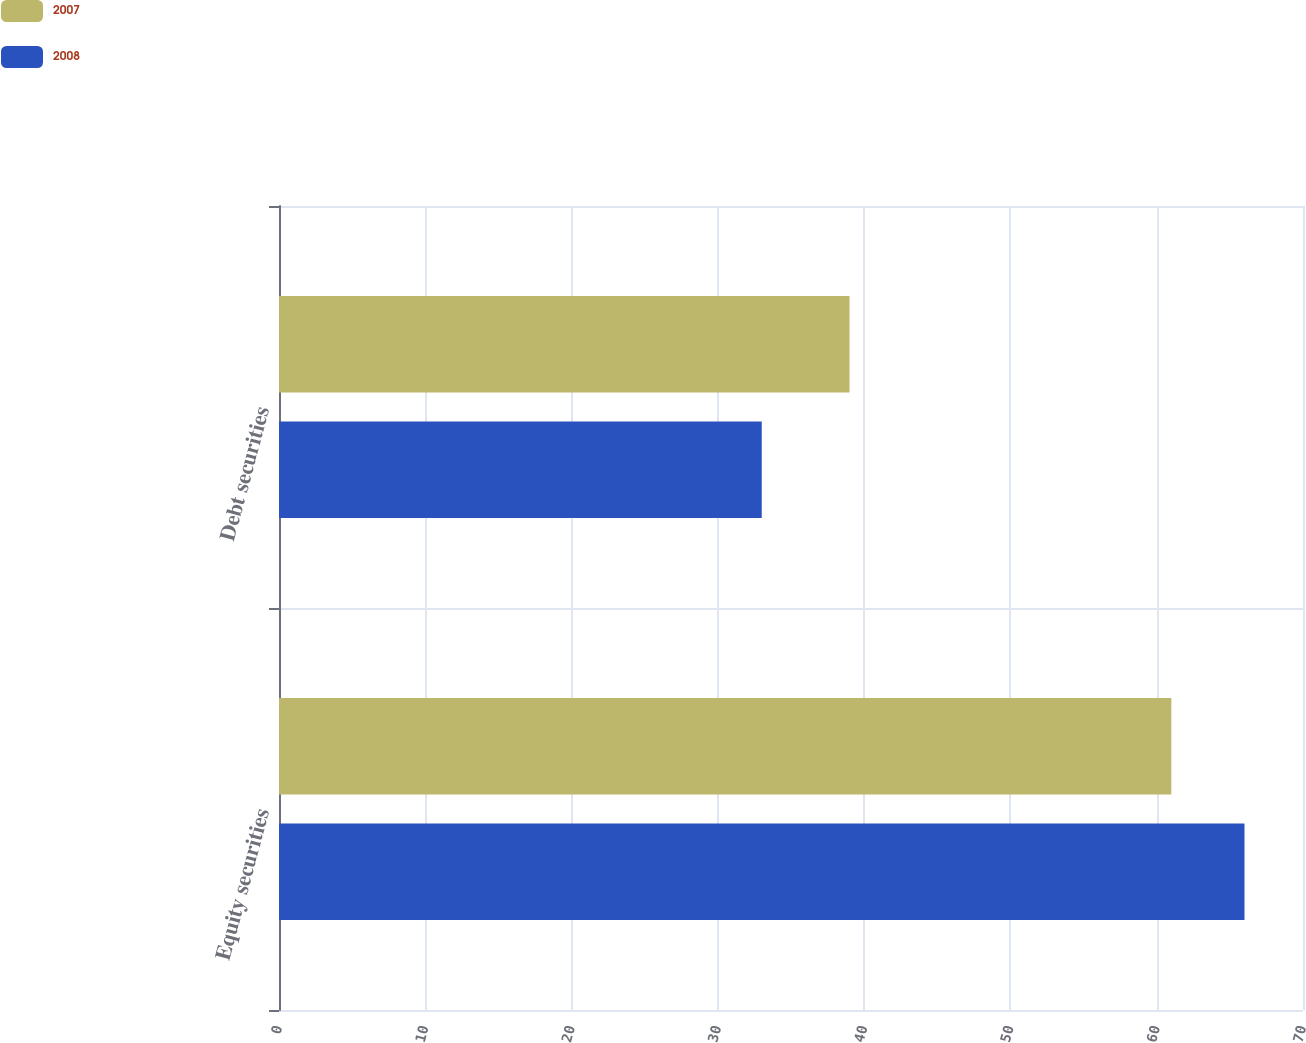Convert chart to OTSL. <chart><loc_0><loc_0><loc_500><loc_500><stacked_bar_chart><ecel><fcel>Equity securities<fcel>Debt securities<nl><fcel>2007<fcel>61<fcel>39<nl><fcel>2008<fcel>66<fcel>33<nl></chart> 